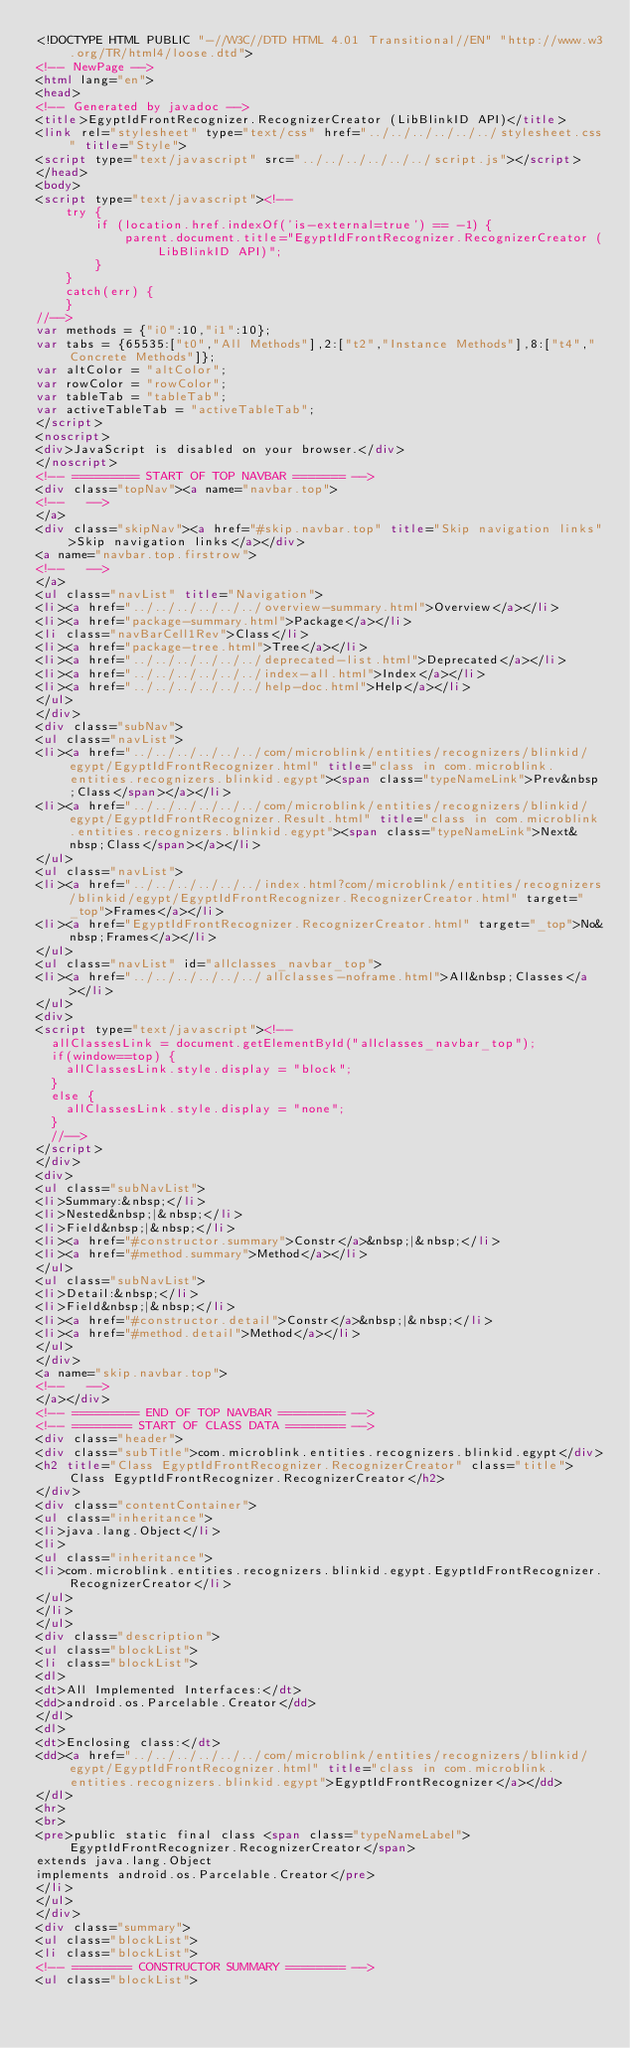<code> <loc_0><loc_0><loc_500><loc_500><_HTML_><!DOCTYPE HTML PUBLIC "-//W3C//DTD HTML 4.01 Transitional//EN" "http://www.w3.org/TR/html4/loose.dtd">
<!-- NewPage -->
<html lang="en">
<head>
<!-- Generated by javadoc -->
<title>EgyptIdFrontRecognizer.RecognizerCreator (LibBlinkID API)</title>
<link rel="stylesheet" type="text/css" href="../../../../../../stylesheet.css" title="Style">
<script type="text/javascript" src="../../../../../../script.js"></script>
</head>
<body>
<script type="text/javascript"><!--
    try {
        if (location.href.indexOf('is-external=true') == -1) {
            parent.document.title="EgyptIdFrontRecognizer.RecognizerCreator (LibBlinkID API)";
        }
    }
    catch(err) {
    }
//-->
var methods = {"i0":10,"i1":10};
var tabs = {65535:["t0","All Methods"],2:["t2","Instance Methods"],8:["t4","Concrete Methods"]};
var altColor = "altColor";
var rowColor = "rowColor";
var tableTab = "tableTab";
var activeTableTab = "activeTableTab";
</script>
<noscript>
<div>JavaScript is disabled on your browser.</div>
</noscript>
<!-- ========= START OF TOP NAVBAR ======= -->
<div class="topNav"><a name="navbar.top">
<!--   -->
</a>
<div class="skipNav"><a href="#skip.navbar.top" title="Skip navigation links">Skip navigation links</a></div>
<a name="navbar.top.firstrow">
<!--   -->
</a>
<ul class="navList" title="Navigation">
<li><a href="../../../../../../overview-summary.html">Overview</a></li>
<li><a href="package-summary.html">Package</a></li>
<li class="navBarCell1Rev">Class</li>
<li><a href="package-tree.html">Tree</a></li>
<li><a href="../../../../../../deprecated-list.html">Deprecated</a></li>
<li><a href="../../../../../../index-all.html">Index</a></li>
<li><a href="../../../../../../help-doc.html">Help</a></li>
</ul>
</div>
<div class="subNav">
<ul class="navList">
<li><a href="../../../../../../com/microblink/entities/recognizers/blinkid/egypt/EgyptIdFrontRecognizer.html" title="class in com.microblink.entities.recognizers.blinkid.egypt"><span class="typeNameLink">Prev&nbsp;Class</span></a></li>
<li><a href="../../../../../../com/microblink/entities/recognizers/blinkid/egypt/EgyptIdFrontRecognizer.Result.html" title="class in com.microblink.entities.recognizers.blinkid.egypt"><span class="typeNameLink">Next&nbsp;Class</span></a></li>
</ul>
<ul class="navList">
<li><a href="../../../../../../index.html?com/microblink/entities/recognizers/blinkid/egypt/EgyptIdFrontRecognizer.RecognizerCreator.html" target="_top">Frames</a></li>
<li><a href="EgyptIdFrontRecognizer.RecognizerCreator.html" target="_top">No&nbsp;Frames</a></li>
</ul>
<ul class="navList" id="allclasses_navbar_top">
<li><a href="../../../../../../allclasses-noframe.html">All&nbsp;Classes</a></li>
</ul>
<div>
<script type="text/javascript"><!--
  allClassesLink = document.getElementById("allclasses_navbar_top");
  if(window==top) {
    allClassesLink.style.display = "block";
  }
  else {
    allClassesLink.style.display = "none";
  }
  //-->
</script>
</div>
<div>
<ul class="subNavList">
<li>Summary:&nbsp;</li>
<li>Nested&nbsp;|&nbsp;</li>
<li>Field&nbsp;|&nbsp;</li>
<li><a href="#constructor.summary">Constr</a>&nbsp;|&nbsp;</li>
<li><a href="#method.summary">Method</a></li>
</ul>
<ul class="subNavList">
<li>Detail:&nbsp;</li>
<li>Field&nbsp;|&nbsp;</li>
<li><a href="#constructor.detail">Constr</a>&nbsp;|&nbsp;</li>
<li><a href="#method.detail">Method</a></li>
</ul>
</div>
<a name="skip.navbar.top">
<!--   -->
</a></div>
<!-- ========= END OF TOP NAVBAR ========= -->
<!-- ======== START OF CLASS DATA ======== -->
<div class="header">
<div class="subTitle">com.microblink.entities.recognizers.blinkid.egypt</div>
<h2 title="Class EgyptIdFrontRecognizer.RecognizerCreator" class="title">Class EgyptIdFrontRecognizer.RecognizerCreator</h2>
</div>
<div class="contentContainer">
<ul class="inheritance">
<li>java.lang.Object</li>
<li>
<ul class="inheritance">
<li>com.microblink.entities.recognizers.blinkid.egypt.EgyptIdFrontRecognizer.RecognizerCreator</li>
</ul>
</li>
</ul>
<div class="description">
<ul class="blockList">
<li class="blockList">
<dl>
<dt>All Implemented Interfaces:</dt>
<dd>android.os.Parcelable.Creator</dd>
</dl>
<dl>
<dt>Enclosing class:</dt>
<dd><a href="../../../../../../com/microblink/entities/recognizers/blinkid/egypt/EgyptIdFrontRecognizer.html" title="class in com.microblink.entities.recognizers.blinkid.egypt">EgyptIdFrontRecognizer</a></dd>
</dl>
<hr>
<br>
<pre>public static final class <span class="typeNameLabel">EgyptIdFrontRecognizer.RecognizerCreator</span>
extends java.lang.Object
implements android.os.Parcelable.Creator</pre>
</li>
</ul>
</div>
<div class="summary">
<ul class="blockList">
<li class="blockList">
<!-- ======== CONSTRUCTOR SUMMARY ======== -->
<ul class="blockList"></code> 